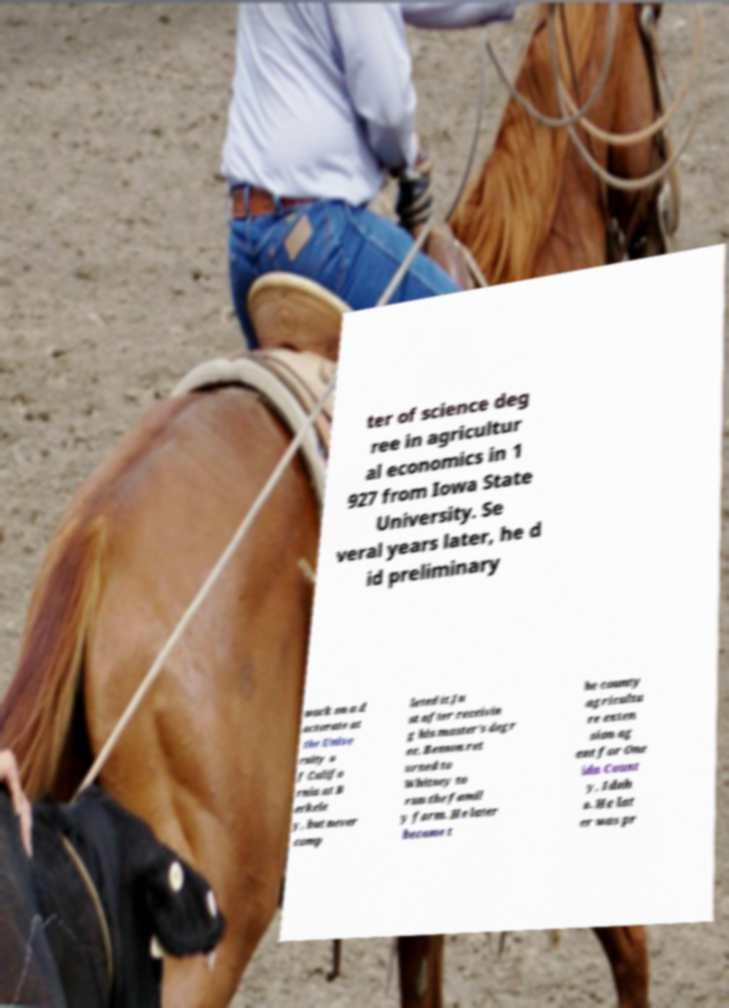Could you assist in decoding the text presented in this image and type it out clearly? ter of science deg ree in agricultur al economics in 1 927 from Iowa State University. Se veral years later, he d id preliminary work on a d octorate at the Unive rsity o f Califo rnia at B erkele y, but never comp leted it.Ju st after receivin g his master's degr ee, Benson ret urned to Whitney to run the famil y farm. He later became t he county agricultu re exten sion ag ent for One ida Count y, Idah o. He lat er was pr 